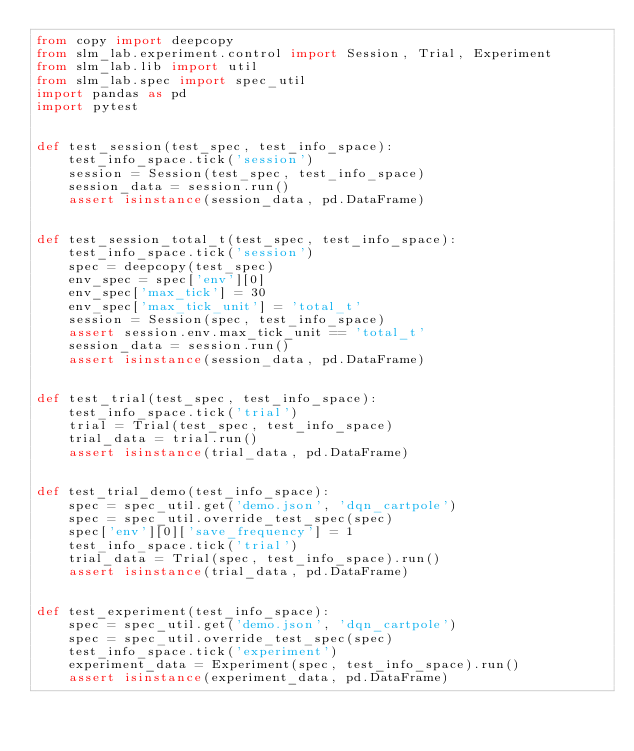<code> <loc_0><loc_0><loc_500><loc_500><_Python_>from copy import deepcopy
from slm_lab.experiment.control import Session, Trial, Experiment
from slm_lab.lib import util
from slm_lab.spec import spec_util
import pandas as pd
import pytest


def test_session(test_spec, test_info_space):
    test_info_space.tick('session')
    session = Session(test_spec, test_info_space)
    session_data = session.run()
    assert isinstance(session_data, pd.DataFrame)


def test_session_total_t(test_spec, test_info_space):
    test_info_space.tick('session')
    spec = deepcopy(test_spec)
    env_spec = spec['env'][0]
    env_spec['max_tick'] = 30
    env_spec['max_tick_unit'] = 'total_t'
    session = Session(spec, test_info_space)
    assert session.env.max_tick_unit == 'total_t'
    session_data = session.run()
    assert isinstance(session_data, pd.DataFrame)


def test_trial(test_spec, test_info_space):
    test_info_space.tick('trial')
    trial = Trial(test_spec, test_info_space)
    trial_data = trial.run()
    assert isinstance(trial_data, pd.DataFrame)


def test_trial_demo(test_info_space):
    spec = spec_util.get('demo.json', 'dqn_cartpole')
    spec = spec_util.override_test_spec(spec)
    spec['env'][0]['save_frequency'] = 1
    test_info_space.tick('trial')
    trial_data = Trial(spec, test_info_space).run()
    assert isinstance(trial_data, pd.DataFrame)


def test_experiment(test_info_space):
    spec = spec_util.get('demo.json', 'dqn_cartpole')
    spec = spec_util.override_test_spec(spec)
    test_info_space.tick('experiment')
    experiment_data = Experiment(spec, test_info_space).run()
    assert isinstance(experiment_data, pd.DataFrame)
</code> 